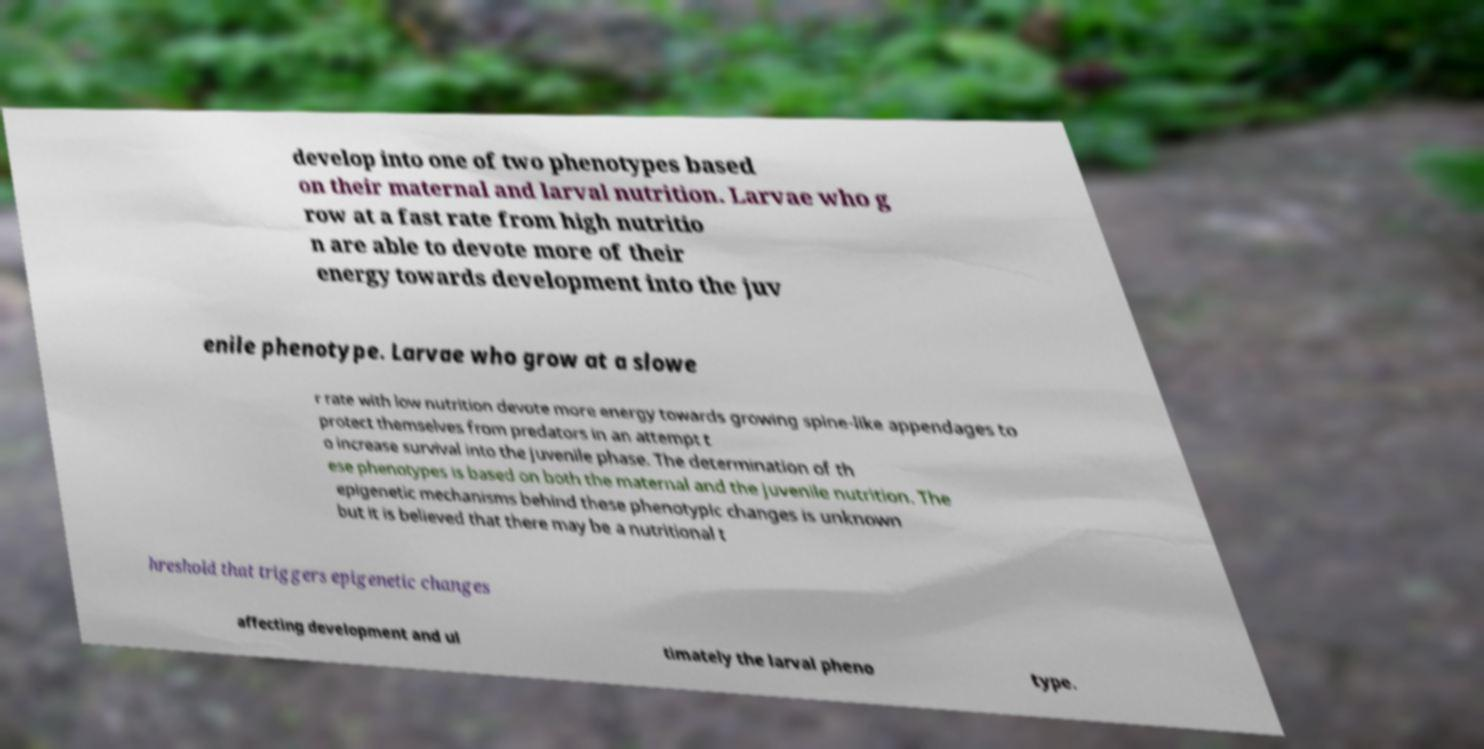Can you read and provide the text displayed in the image?This photo seems to have some interesting text. Can you extract and type it out for me? develop into one of two phenotypes based on their maternal and larval nutrition. Larvae who g row at a fast rate from high nutritio n are able to devote more of their energy towards development into the juv enile phenotype. Larvae who grow at a slowe r rate with low nutrition devote more energy towards growing spine-like appendages to protect themselves from predators in an attempt t o increase survival into the juvenile phase. The determination of th ese phenotypes is based on both the maternal and the juvenile nutrition. The epigenetic mechanisms behind these phenotypic changes is unknown but it is believed that there may be a nutritional t hreshold that triggers epigenetic changes affecting development and ul timately the larval pheno type. 